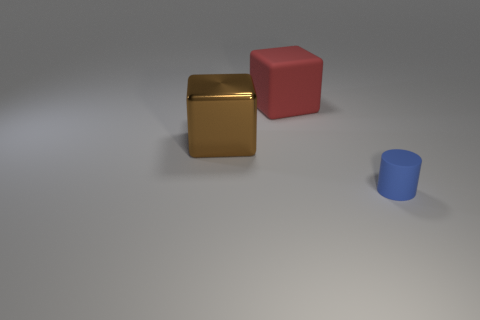Is there any object that stands out in terms of texture or color? The golden cube stands out due to its reflective texture and distinct color, which contrasts sharply with the matte surfaces and more subdued hues of the other objects.  How would you describe the arrangement of objects in this scene? The arrangement of objects is simple and symmetrically spaced. There is a deliberate and orderly placement that provides a sense of balance, with objects positioned at varying distances from each other. 